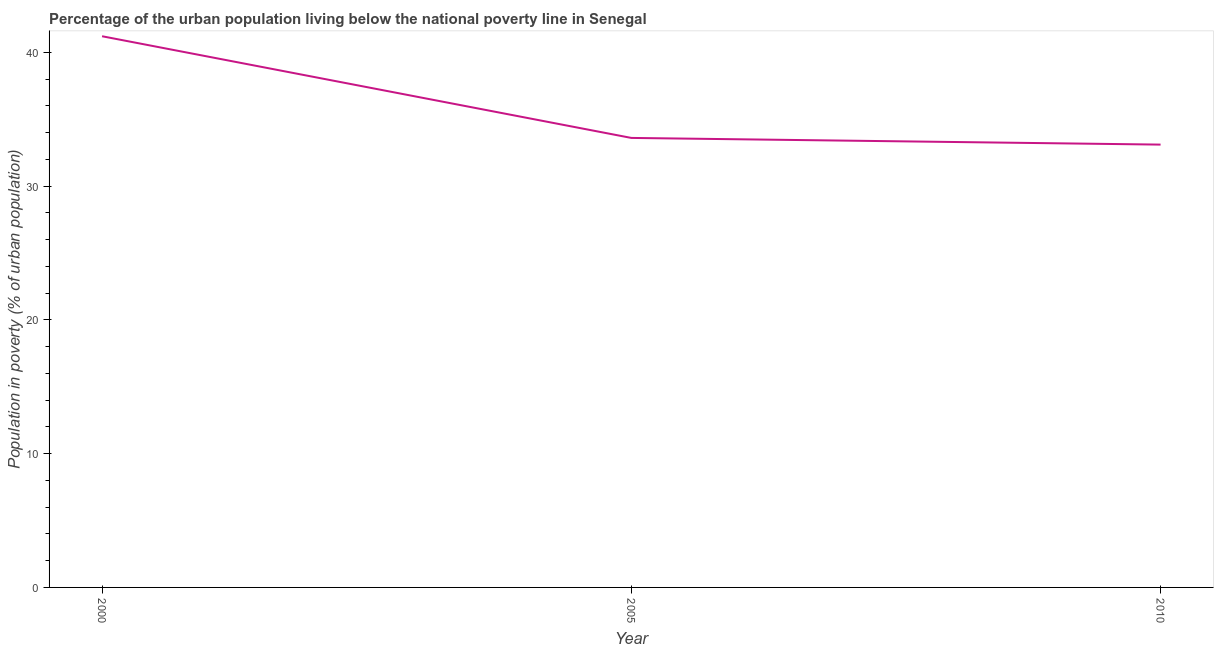What is the percentage of urban population living below poverty line in 2000?
Your answer should be very brief. 41.2. Across all years, what is the maximum percentage of urban population living below poverty line?
Provide a short and direct response. 41.2. Across all years, what is the minimum percentage of urban population living below poverty line?
Offer a terse response. 33.1. In which year was the percentage of urban population living below poverty line minimum?
Offer a terse response. 2010. What is the sum of the percentage of urban population living below poverty line?
Give a very brief answer. 107.9. What is the difference between the percentage of urban population living below poverty line in 2000 and 2005?
Offer a terse response. 7.6. What is the average percentage of urban population living below poverty line per year?
Give a very brief answer. 35.97. What is the median percentage of urban population living below poverty line?
Provide a short and direct response. 33.6. Do a majority of the years between 2000 and 2005 (inclusive) have percentage of urban population living below poverty line greater than 8 %?
Give a very brief answer. Yes. What is the ratio of the percentage of urban population living below poverty line in 2005 to that in 2010?
Keep it short and to the point. 1.02. What is the difference between the highest and the second highest percentage of urban population living below poverty line?
Your answer should be compact. 7.6. What is the difference between the highest and the lowest percentage of urban population living below poverty line?
Keep it short and to the point. 8.1. Does the percentage of urban population living below poverty line monotonically increase over the years?
Ensure brevity in your answer.  No. How many years are there in the graph?
Ensure brevity in your answer.  3. What is the difference between two consecutive major ticks on the Y-axis?
Keep it short and to the point. 10. Are the values on the major ticks of Y-axis written in scientific E-notation?
Make the answer very short. No. Does the graph contain any zero values?
Your answer should be compact. No. Does the graph contain grids?
Offer a terse response. No. What is the title of the graph?
Provide a succinct answer. Percentage of the urban population living below the national poverty line in Senegal. What is the label or title of the X-axis?
Ensure brevity in your answer.  Year. What is the label or title of the Y-axis?
Ensure brevity in your answer.  Population in poverty (% of urban population). What is the Population in poverty (% of urban population) in 2000?
Your answer should be compact. 41.2. What is the Population in poverty (% of urban population) in 2005?
Your answer should be compact. 33.6. What is the Population in poverty (% of urban population) of 2010?
Make the answer very short. 33.1. What is the ratio of the Population in poverty (% of urban population) in 2000 to that in 2005?
Provide a succinct answer. 1.23. What is the ratio of the Population in poverty (% of urban population) in 2000 to that in 2010?
Offer a terse response. 1.25. 